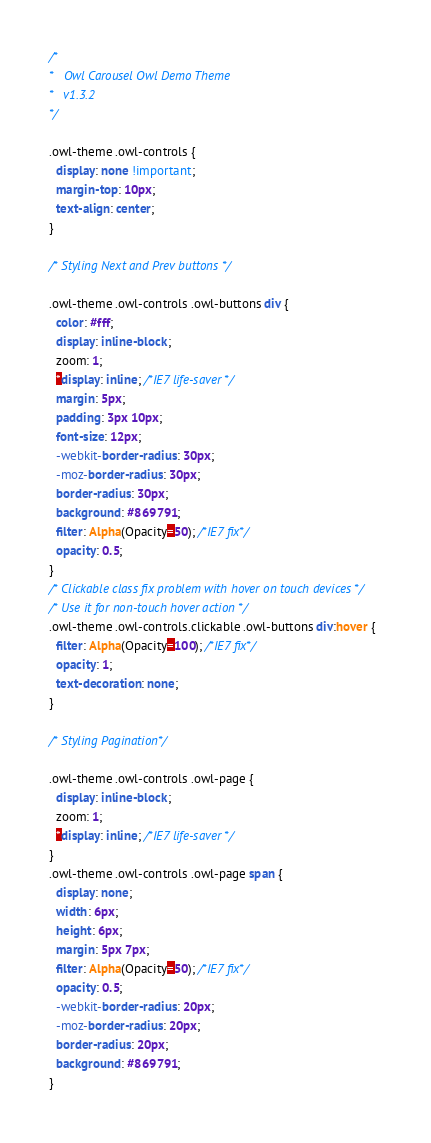<code> <loc_0><loc_0><loc_500><loc_500><_CSS_>/*
* 	Owl Carousel Owl Demo Theme 
*	v1.3.2
*/

.owl-theme .owl-controls {
  display: none !important;
  margin-top: 10px;
  text-align: center;
}

/* Styling Next and Prev buttons */

.owl-theme .owl-controls .owl-buttons div {
  color: #fff;
  display: inline-block;
  zoom: 1;
  *display: inline; /*IE7 life-saver */
  margin: 5px;
  padding: 3px 10px;
  font-size: 12px;
  -webkit-border-radius: 30px;
  -moz-border-radius: 30px;
  border-radius: 30px;
  background: #869791;
  filter: Alpha(Opacity=50); /*IE7 fix*/
  opacity: 0.5;
}
/* Clickable class fix problem with hover on touch devices */
/* Use it for non-touch hover action */
.owl-theme .owl-controls.clickable .owl-buttons div:hover {
  filter: Alpha(Opacity=100); /*IE7 fix*/
  opacity: 1;
  text-decoration: none;
}

/* Styling Pagination*/

.owl-theme .owl-controls .owl-page {
  display: inline-block;
  zoom: 1;
  *display: inline; /*IE7 life-saver */
}
.owl-theme .owl-controls .owl-page span {
  display: none;
  width: 6px;
  height: 6px;
  margin: 5px 7px;
  filter: Alpha(Opacity=50); /*IE7 fix*/
  opacity: 0.5;
  -webkit-border-radius: 20px;
  -moz-border-radius: 20px;
  border-radius: 20px;
  background: #869791;
}
</code> 